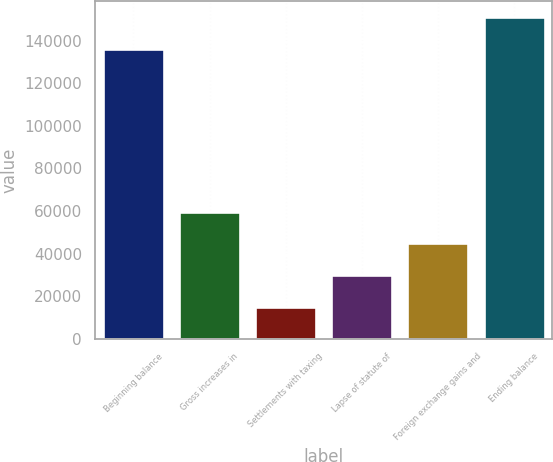<chart> <loc_0><loc_0><loc_500><loc_500><bar_chart><fcel>Beginning balance<fcel>Gross increases in<fcel>Settlements with taxing<fcel>Lapse of statute of<fcel>Foreign exchange gains and<fcel>Ending balance<nl><fcel>136098<fcel>59625.6<fcel>15014.4<fcel>29884.8<fcel>44755.2<fcel>150968<nl></chart> 